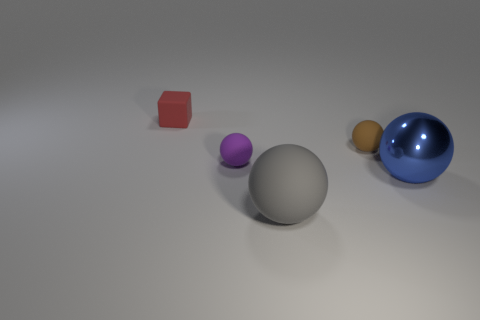Add 2 large gray rubber spheres. How many objects exist? 7 Subtract all blocks. How many objects are left? 4 Subtract all blue metallic cylinders. Subtract all gray things. How many objects are left? 4 Add 4 brown spheres. How many brown spheres are left? 5 Add 2 tiny cyan rubber cylinders. How many tiny cyan rubber cylinders exist? 2 Subtract 0 green spheres. How many objects are left? 5 